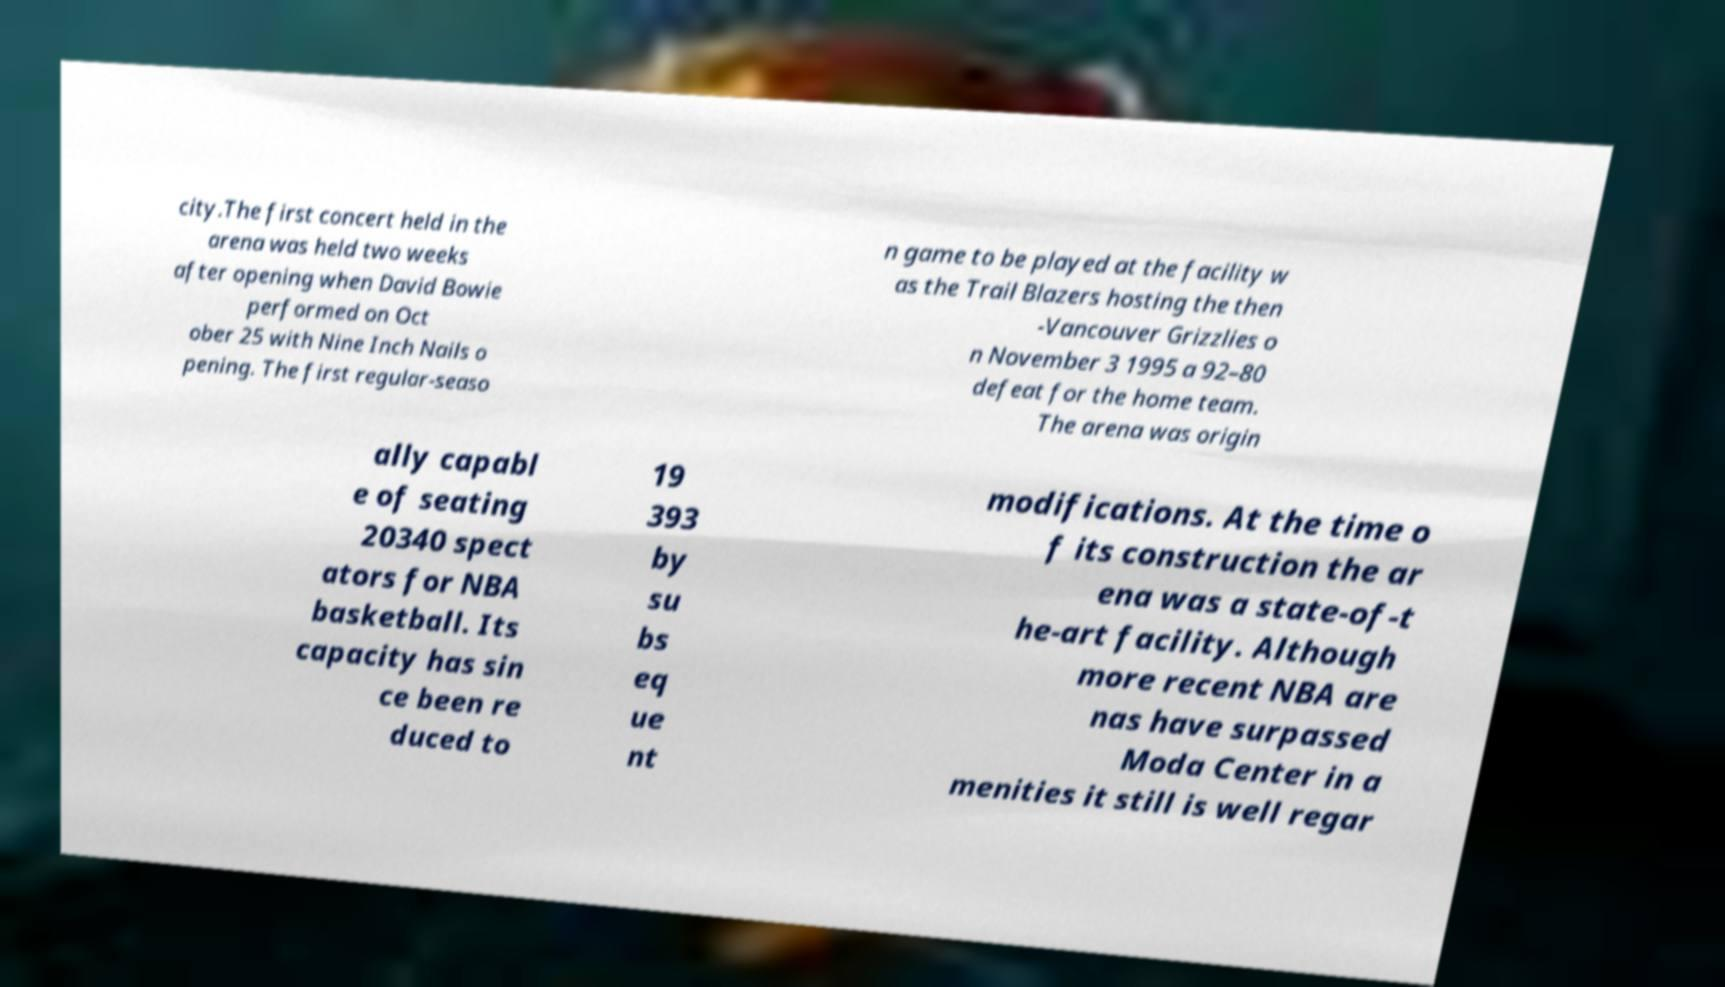Please identify and transcribe the text found in this image. city.The first concert held in the arena was held two weeks after opening when David Bowie performed on Oct ober 25 with Nine Inch Nails o pening. The first regular-seaso n game to be played at the facility w as the Trail Blazers hosting the then -Vancouver Grizzlies o n November 3 1995 a 92–80 defeat for the home team. The arena was origin ally capabl e of seating 20340 spect ators for NBA basketball. Its capacity has sin ce been re duced to 19 393 by su bs eq ue nt modifications. At the time o f its construction the ar ena was a state-of-t he-art facility. Although more recent NBA are nas have surpassed Moda Center in a menities it still is well regar 